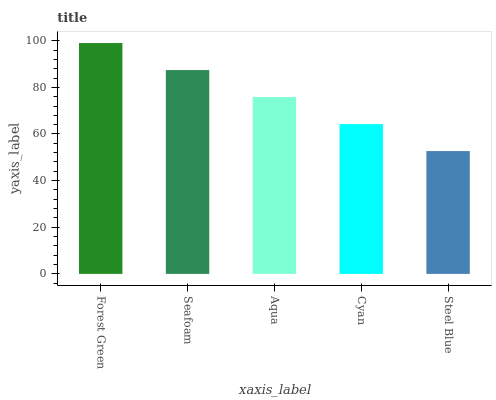Is Seafoam the minimum?
Answer yes or no. No. Is Seafoam the maximum?
Answer yes or no. No. Is Forest Green greater than Seafoam?
Answer yes or no. Yes. Is Seafoam less than Forest Green?
Answer yes or no. Yes. Is Seafoam greater than Forest Green?
Answer yes or no. No. Is Forest Green less than Seafoam?
Answer yes or no. No. Is Aqua the high median?
Answer yes or no. Yes. Is Aqua the low median?
Answer yes or no. Yes. Is Seafoam the high median?
Answer yes or no. No. Is Forest Green the low median?
Answer yes or no. No. 